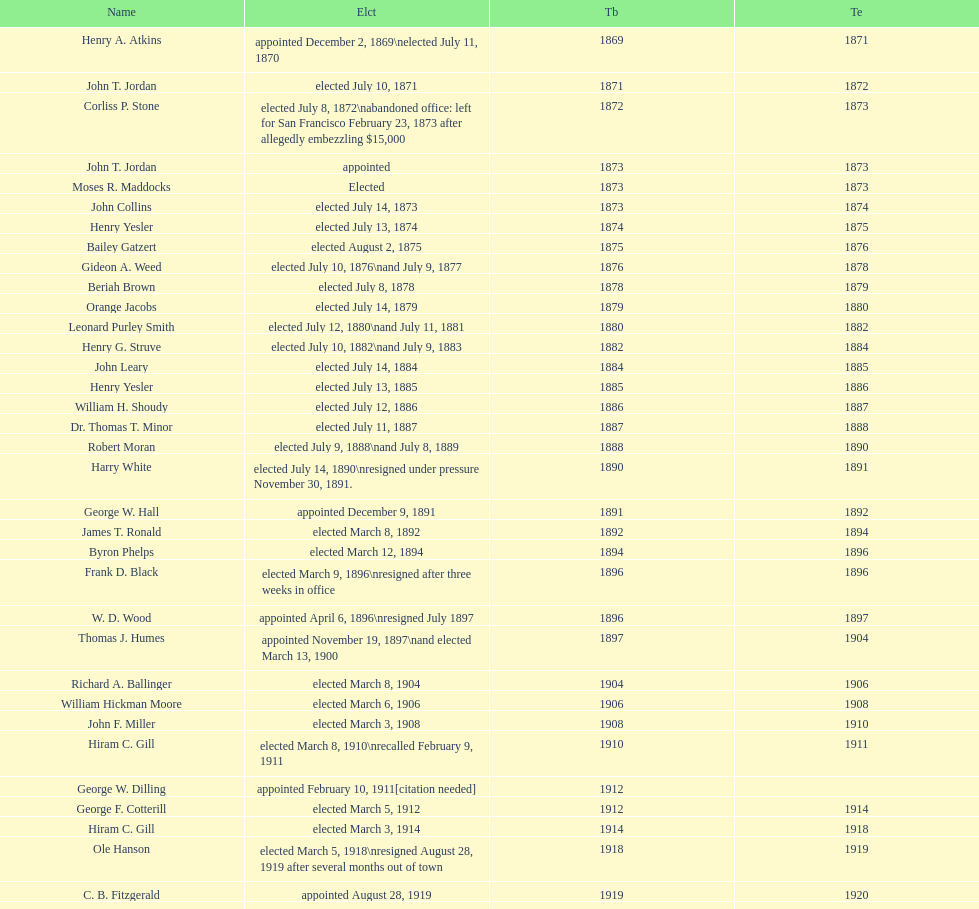Did charles royer hold office longer than paul schell? Yes. 